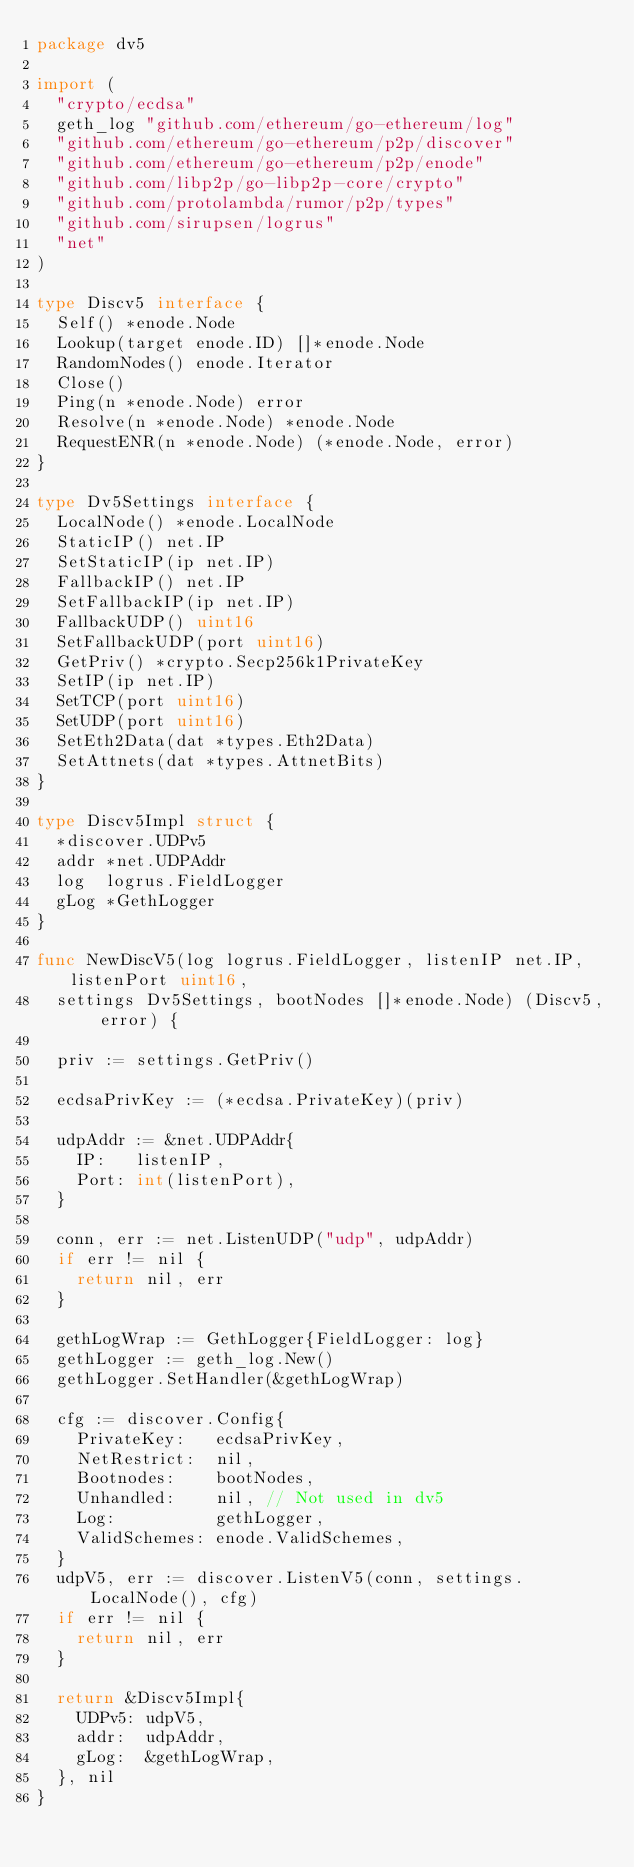Convert code to text. <code><loc_0><loc_0><loc_500><loc_500><_Go_>package dv5

import (
	"crypto/ecdsa"
	geth_log "github.com/ethereum/go-ethereum/log"
	"github.com/ethereum/go-ethereum/p2p/discover"
	"github.com/ethereum/go-ethereum/p2p/enode"
	"github.com/libp2p/go-libp2p-core/crypto"
	"github.com/protolambda/rumor/p2p/types"
	"github.com/sirupsen/logrus"
	"net"
)

type Discv5 interface {
	Self() *enode.Node
	Lookup(target enode.ID) []*enode.Node
	RandomNodes() enode.Iterator
	Close()
	Ping(n *enode.Node) error
	Resolve(n *enode.Node) *enode.Node
	RequestENR(n *enode.Node) (*enode.Node, error)
}

type Dv5Settings interface {
	LocalNode() *enode.LocalNode
	StaticIP() net.IP
	SetStaticIP(ip net.IP)
	FallbackIP() net.IP
	SetFallbackIP(ip net.IP)
	FallbackUDP() uint16
	SetFallbackUDP(port uint16)
	GetPriv() *crypto.Secp256k1PrivateKey
	SetIP(ip net.IP)
	SetTCP(port uint16)
	SetUDP(port uint16)
	SetEth2Data(dat *types.Eth2Data)
	SetAttnets(dat *types.AttnetBits)
}

type Discv5Impl struct {
	*discover.UDPv5
	addr *net.UDPAddr
	log  logrus.FieldLogger
	gLog *GethLogger
}

func NewDiscV5(log logrus.FieldLogger, listenIP net.IP, listenPort uint16,
	settings Dv5Settings, bootNodes []*enode.Node) (Discv5, error) {

	priv := settings.GetPriv()

	ecdsaPrivKey := (*ecdsa.PrivateKey)(priv)

	udpAddr := &net.UDPAddr{
		IP:   listenIP,
		Port: int(listenPort),
	}

	conn, err := net.ListenUDP("udp", udpAddr)
	if err != nil {
		return nil, err
	}

	gethLogWrap := GethLogger{FieldLogger: log}
	gethLogger := geth_log.New()
	gethLogger.SetHandler(&gethLogWrap)

	cfg := discover.Config{
		PrivateKey:   ecdsaPrivKey,
		NetRestrict:  nil,
		Bootnodes:    bootNodes,
		Unhandled:    nil, // Not used in dv5
		Log:          gethLogger,
		ValidSchemes: enode.ValidSchemes,
	}
	udpV5, err := discover.ListenV5(conn, settings.LocalNode(), cfg)
	if err != nil {
		return nil, err
	}

	return &Discv5Impl{
		UDPv5: udpV5,
		addr:  udpAddr,
		gLog:  &gethLogWrap,
	}, nil
}
</code> 